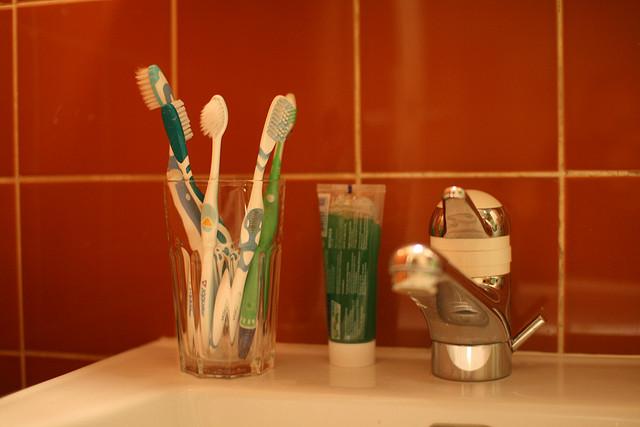What room is pictured in this scene?
Answer briefly. Bathroom. Where are the toothbrushes stored?
Answer briefly. Bathroom. How many people live here?
Keep it brief. 5. 